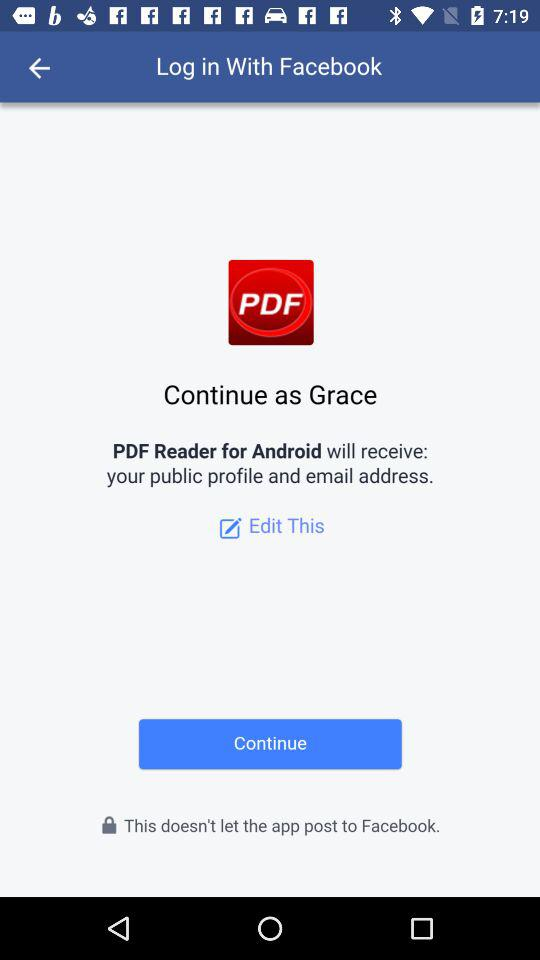Through what application can we log in? You can log in through "Facebook". 